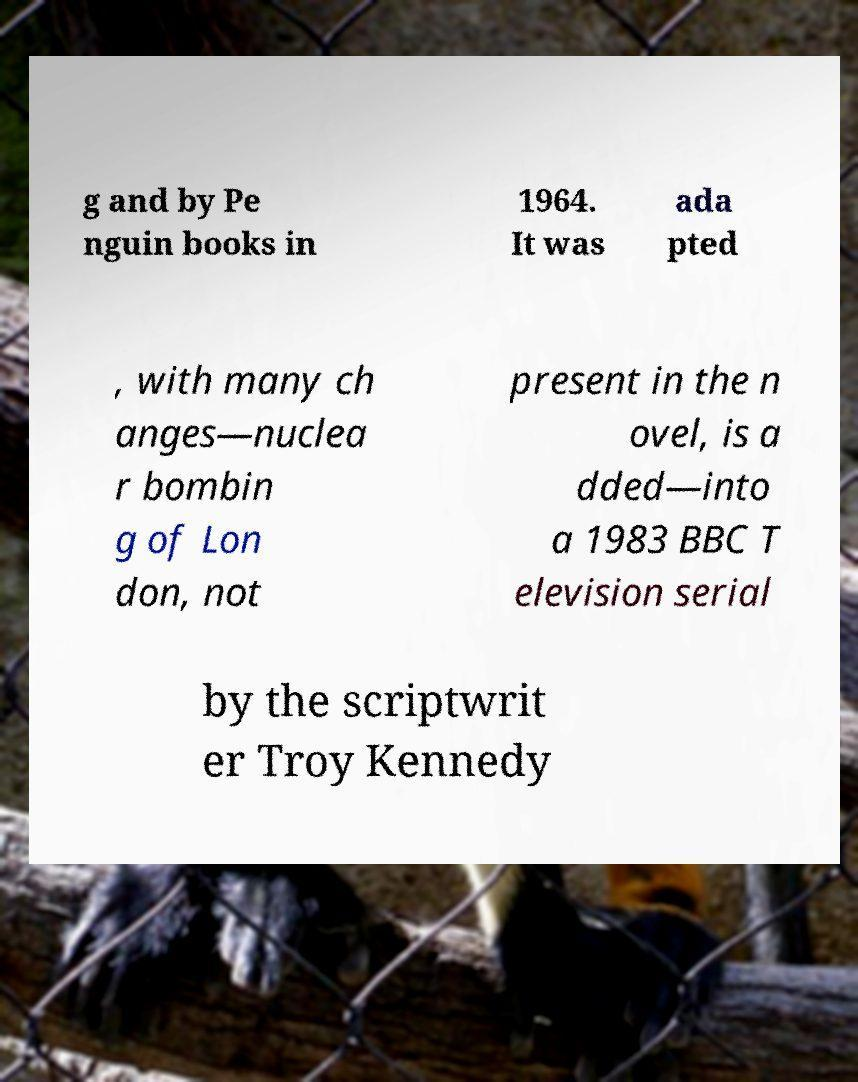Could you extract and type out the text from this image? g and by Pe nguin books in 1964. It was ada pted , with many ch anges—nuclea r bombin g of Lon don, not present in the n ovel, is a dded—into a 1983 BBC T elevision serial by the scriptwrit er Troy Kennedy 